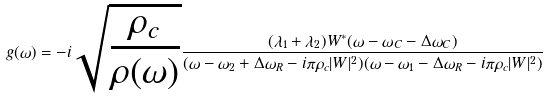<formula> <loc_0><loc_0><loc_500><loc_500>g ( \omega ) = - i \sqrt { \frac { \rho _ { c } } { \rho ( \omega ) } } \frac { ( \lambda _ { 1 } + \lambda _ { 2 } ) W ^ { \ast } ( \omega - \omega _ { C } - \Delta \omega _ { C } ) } { ( \omega - \omega _ { 2 } + \Delta \omega _ { R } - i \pi \rho _ { c } | W | ^ { 2 } ) ( \omega - \omega _ { 1 } - \Delta \omega _ { R } - i \pi \rho _ { c } | W | ^ { 2 } ) }</formula> 